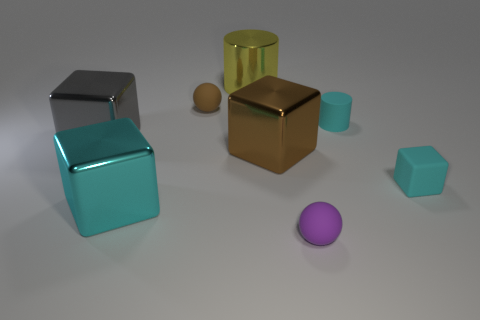Subtract 2 blocks. How many blocks are left? 2 Subtract all blue cubes. Subtract all green balls. How many cubes are left? 4 Add 1 spheres. How many objects exist? 9 Subtract all cylinders. How many objects are left? 6 Subtract 0 green cylinders. How many objects are left? 8 Subtract all tiny rubber blocks. Subtract all matte blocks. How many objects are left? 6 Add 1 big yellow shiny things. How many big yellow shiny things are left? 2 Add 3 big yellow rubber cubes. How many big yellow rubber cubes exist? 3 